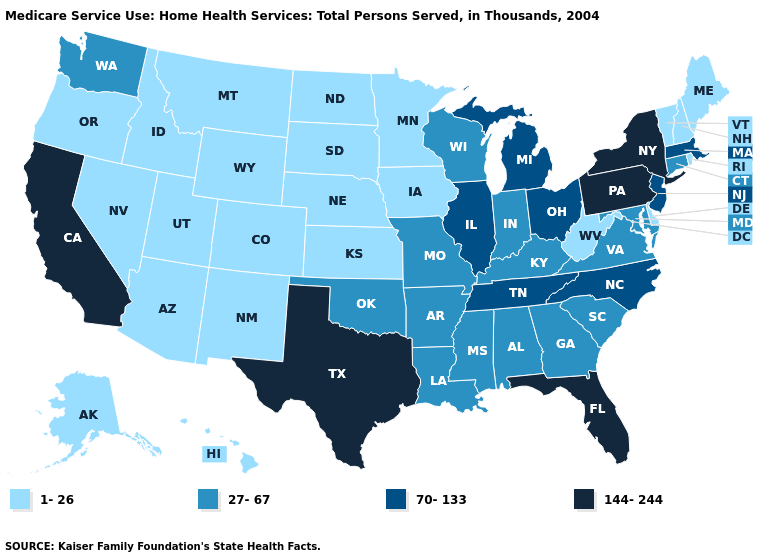Name the states that have a value in the range 144-244?
Give a very brief answer. California, Florida, New York, Pennsylvania, Texas. Name the states that have a value in the range 1-26?
Quick response, please. Alaska, Arizona, Colorado, Delaware, Hawaii, Idaho, Iowa, Kansas, Maine, Minnesota, Montana, Nebraska, Nevada, New Hampshire, New Mexico, North Dakota, Oregon, Rhode Island, South Dakota, Utah, Vermont, West Virginia, Wyoming. What is the value of New Jersey?
Be succinct. 70-133. Does Indiana have the highest value in the MidWest?
Write a very short answer. No. Does Kentucky have a lower value than Georgia?
Answer briefly. No. What is the lowest value in the West?
Be succinct. 1-26. What is the value of Hawaii?
Write a very short answer. 1-26. What is the highest value in the USA?
Give a very brief answer. 144-244. Name the states that have a value in the range 27-67?
Answer briefly. Alabama, Arkansas, Connecticut, Georgia, Indiana, Kentucky, Louisiana, Maryland, Mississippi, Missouri, Oklahoma, South Carolina, Virginia, Washington, Wisconsin. Among the states that border Arizona , does California have the highest value?
Concise answer only. Yes. Does the first symbol in the legend represent the smallest category?
Keep it brief. Yes. Name the states that have a value in the range 1-26?
Answer briefly. Alaska, Arizona, Colorado, Delaware, Hawaii, Idaho, Iowa, Kansas, Maine, Minnesota, Montana, Nebraska, Nevada, New Hampshire, New Mexico, North Dakota, Oregon, Rhode Island, South Dakota, Utah, Vermont, West Virginia, Wyoming. What is the value of Arkansas?
Write a very short answer. 27-67. What is the lowest value in the Northeast?
Quick response, please. 1-26. Name the states that have a value in the range 70-133?
Short answer required. Illinois, Massachusetts, Michigan, New Jersey, North Carolina, Ohio, Tennessee. 